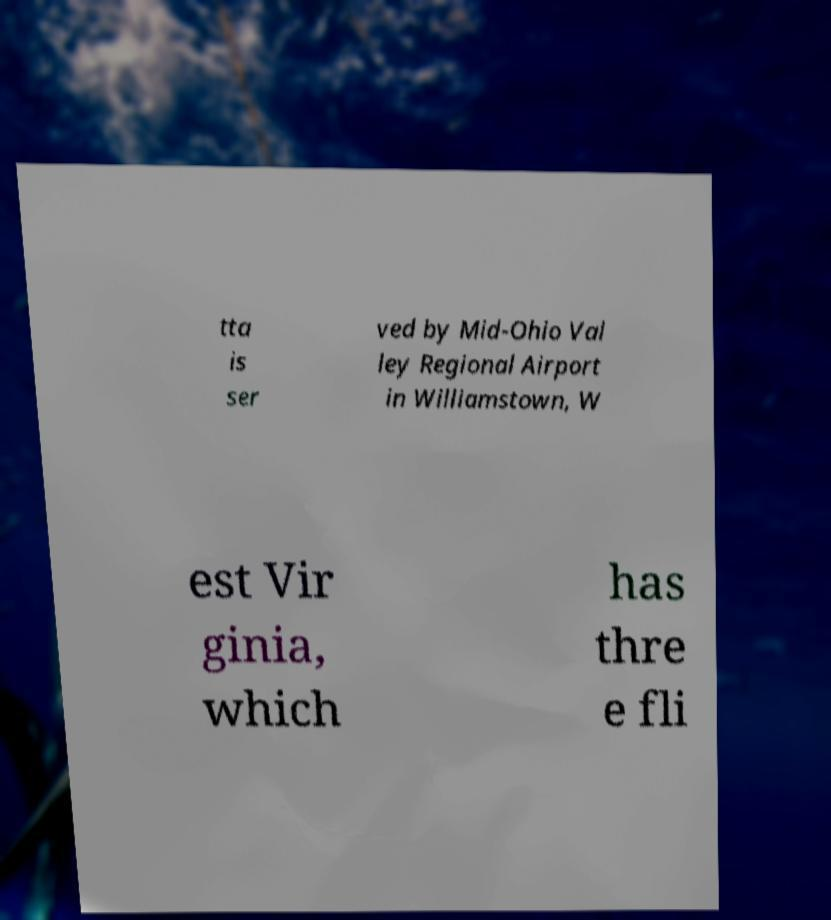There's text embedded in this image that I need extracted. Can you transcribe it verbatim? tta is ser ved by Mid-Ohio Val ley Regional Airport in Williamstown, W est Vir ginia, which has thre e fli 